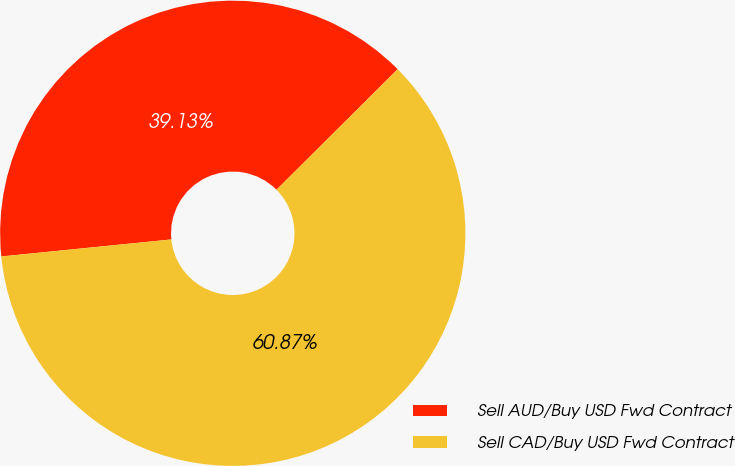Convert chart to OTSL. <chart><loc_0><loc_0><loc_500><loc_500><pie_chart><fcel>Sell AUD/Buy USD Fwd Contract<fcel>Sell CAD/Buy USD Fwd Contract<nl><fcel>39.13%<fcel>60.87%<nl></chart> 